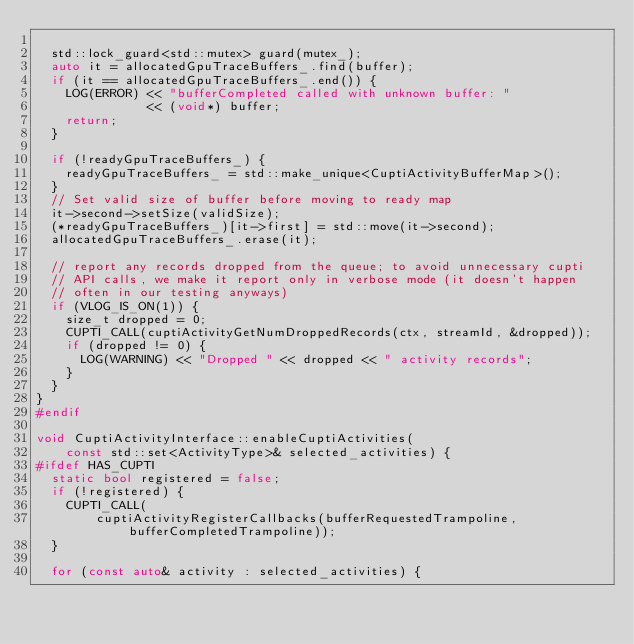<code> <loc_0><loc_0><loc_500><loc_500><_C++_>
  std::lock_guard<std::mutex> guard(mutex_);
  auto it = allocatedGpuTraceBuffers_.find(buffer);
  if (it == allocatedGpuTraceBuffers_.end()) {
    LOG(ERROR) << "bufferCompleted called with unknown buffer: "
               << (void*) buffer;
    return;
  }

  if (!readyGpuTraceBuffers_) {
    readyGpuTraceBuffers_ = std::make_unique<CuptiActivityBufferMap>();
  }
  // Set valid size of buffer before moving to ready map
  it->second->setSize(validSize);
  (*readyGpuTraceBuffers_)[it->first] = std::move(it->second);
  allocatedGpuTraceBuffers_.erase(it);

  // report any records dropped from the queue; to avoid unnecessary cupti
  // API calls, we make it report only in verbose mode (it doesn't happen
  // often in our testing anyways)
  if (VLOG_IS_ON(1)) {
    size_t dropped = 0;
    CUPTI_CALL(cuptiActivityGetNumDroppedRecords(ctx, streamId, &dropped));
    if (dropped != 0) {
      LOG(WARNING) << "Dropped " << dropped << " activity records";
    }
  }
}
#endif

void CuptiActivityInterface::enableCuptiActivities(
    const std::set<ActivityType>& selected_activities) {
#ifdef HAS_CUPTI
  static bool registered = false;
  if (!registered) {
    CUPTI_CALL(
        cuptiActivityRegisterCallbacks(bufferRequestedTrampoline, bufferCompletedTrampoline));
  }

  for (const auto& activity : selected_activities) {</code> 